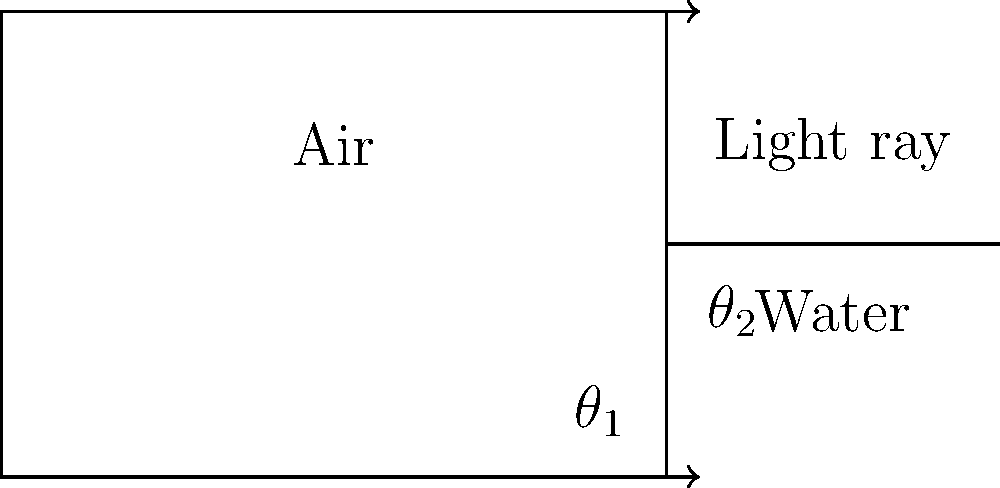A light ray travels from air into water, as shown in the diagram. If the angle of incidence ($\theta_1$) is 45° and the refractive index of water is 1.33, calculate the angle of refraction ($\theta_2$) to the nearest degree. How does this relate to the concept of total internal reflection, a phenomenon your mother might have encountered in her work with fiber optics? Let's approach this step-by-step:

1) We can use Snell's law to solve this problem. The formula is:

   $$n_1 \sin(\theta_1) = n_2 \sin(\theta_2)$$

   Where $n_1$ and $n_2$ are the refractive indices of the two media, and $\theta_1$ and $\theta_2$ are the angles of incidence and refraction respectively.

2) We know:
   - $n_1 = 1$ (refractive index of air)
   - $n_2 = 1.33$ (refractive index of water)
   - $\theta_1 = 45°$

3) Substituting these values into Snell's law:

   $$1 \sin(45°) = 1.33 \sin(\theta_2)$$

4) Simplify:
   $$\sin(45°) = 1.33 \sin(\theta_2)$$
   $$\frac{\sqrt{2}}{2} = 1.33 \sin(\theta_2)$$

5) Solve for $\theta_2$:
   $$\sin(\theta_2) = \frac{\sqrt{2}}{2 * 1.33} \approx 0.5303$$
   $$\theta_2 = \arcsin(0.5303) \approx 32.0°$$

6) Rounding to the nearest degree: $\theta_2 = 32°$

Regarding total internal reflection:
This phenomenon occurs when light travels from a medium with a higher refractive index to one with a lower refractive index, at an angle greater than the critical angle. In fiber optics, this principle is used to transmit light signals over long distances with minimal loss. The critical angle for the air-water interface is about 48.6°. If the angle of incidence in water were greater than this, the light would be totally reflected back into the water instead of refracting into the air.
Answer: 32° 